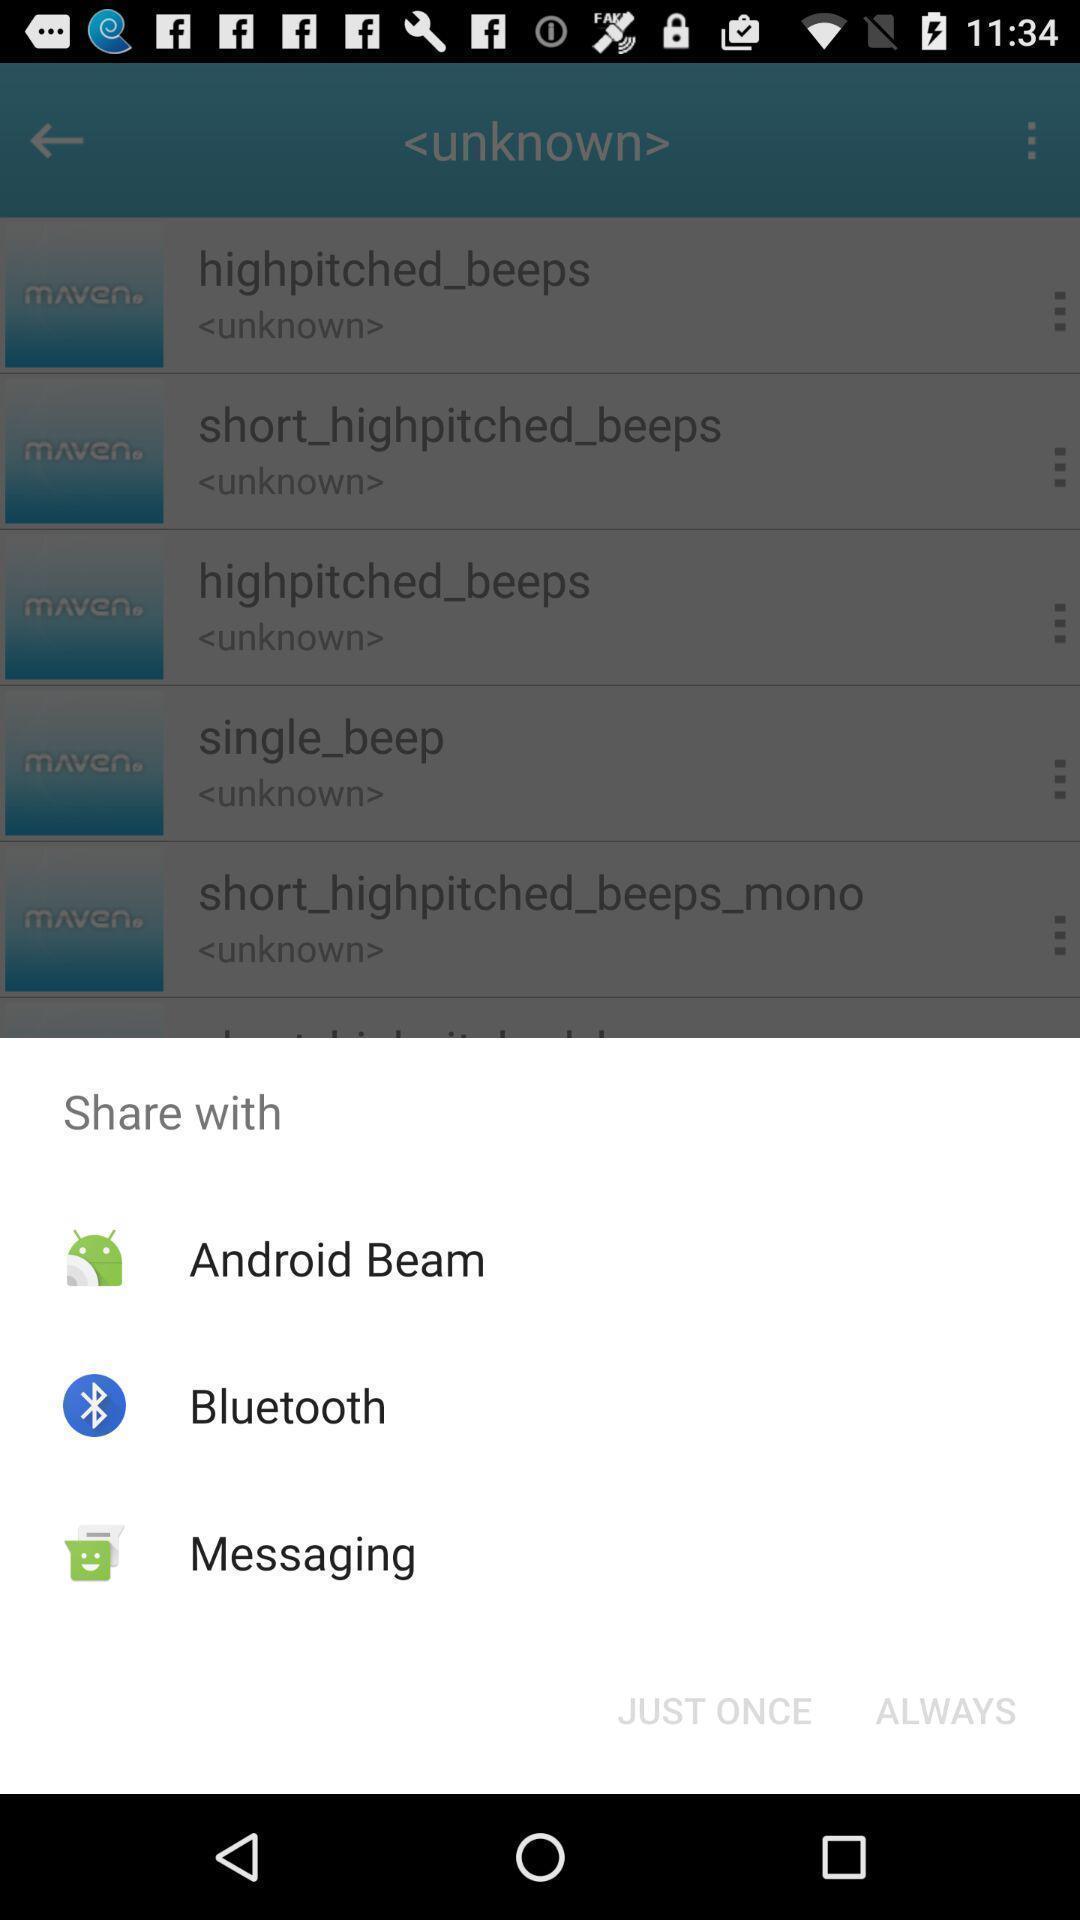Describe the visual elements of this screenshot. Pop-up showing the multiple share options. 